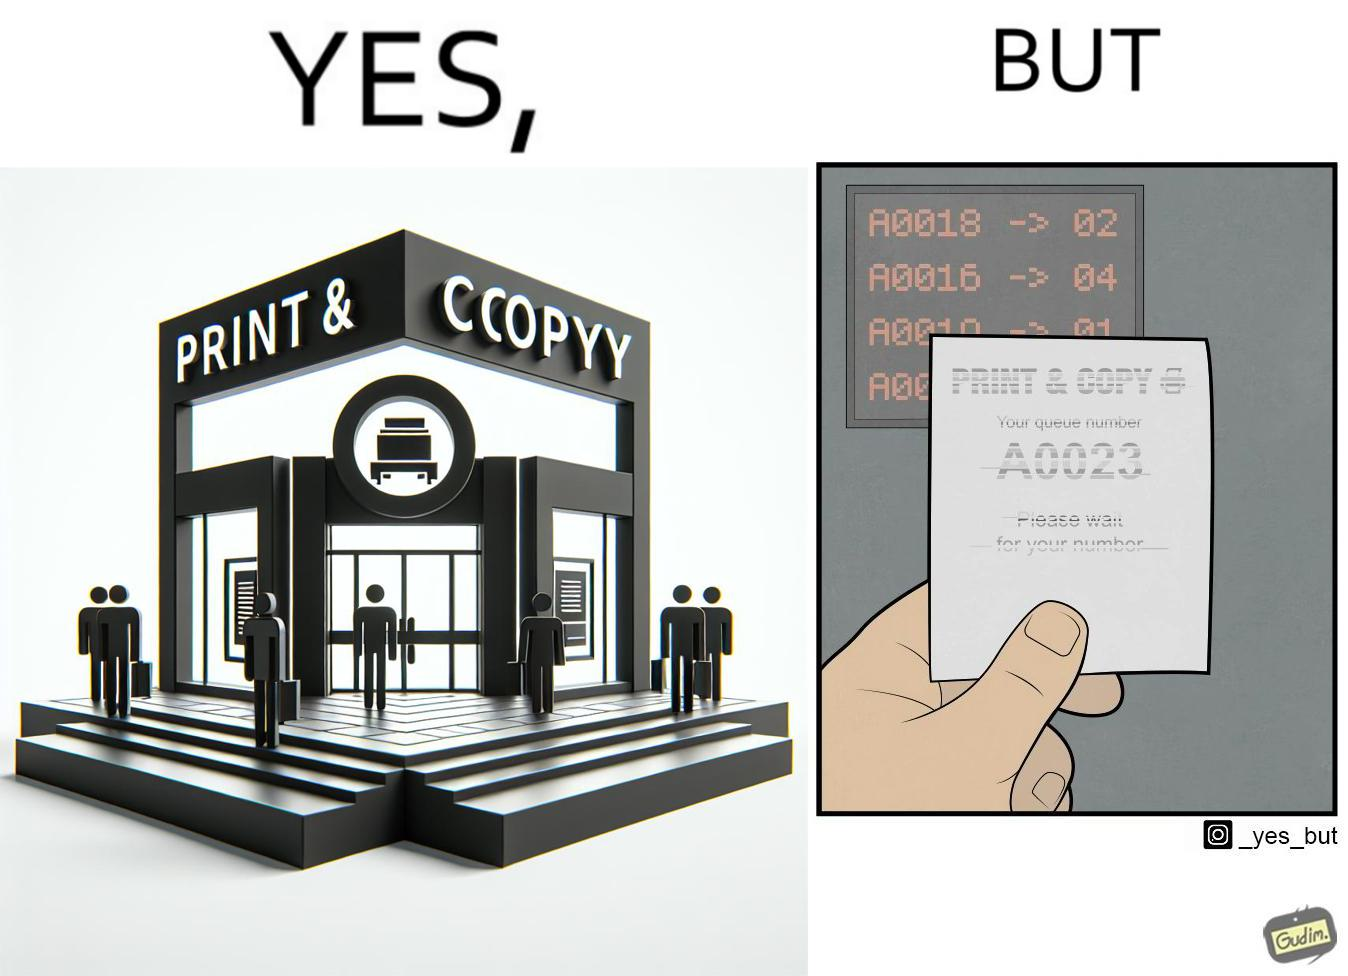What is the satirical meaning behind this image? The image is ironic, as the waiting slip in a "Print & Copy" Centre is printed with insufficient printing ink. 